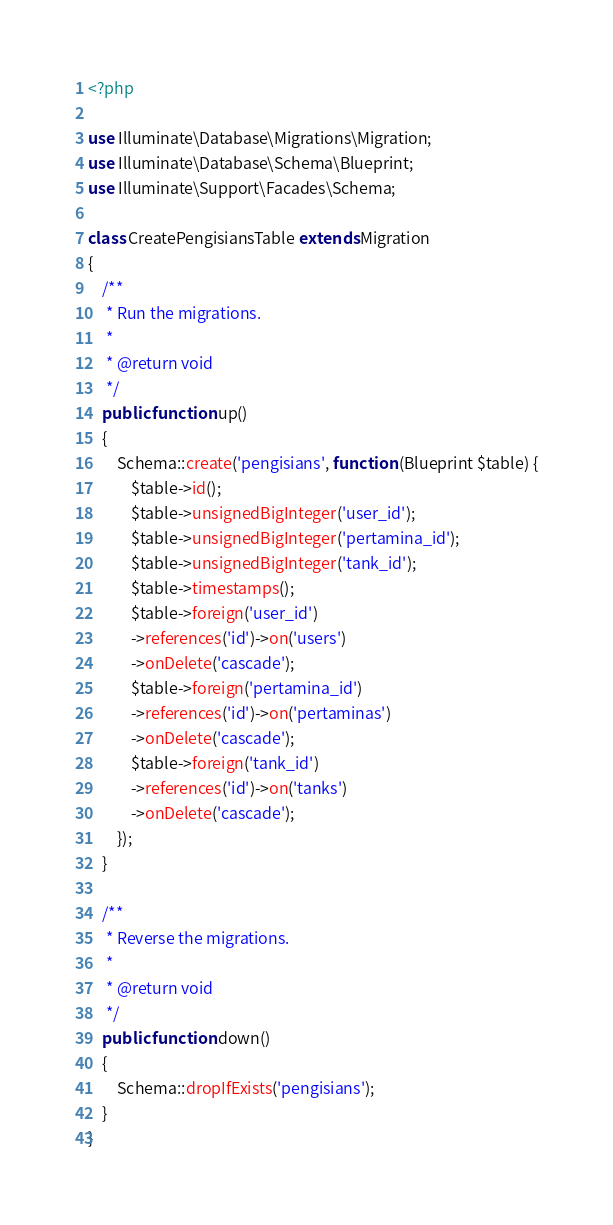Convert code to text. <code><loc_0><loc_0><loc_500><loc_500><_PHP_><?php

use Illuminate\Database\Migrations\Migration;
use Illuminate\Database\Schema\Blueprint;
use Illuminate\Support\Facades\Schema;

class CreatePengisiansTable extends Migration
{
    /**
     * Run the migrations.
     *
     * @return void
     */
    public function up()
    {
        Schema::create('pengisians', function (Blueprint $table) {
            $table->id();
            $table->unsignedBigInteger('user_id');
            $table->unsignedBigInteger('pertamina_id');
            $table->unsignedBigInteger('tank_id');
            $table->timestamps();
            $table->foreign('user_id')
            ->references('id')->on('users')
            ->onDelete('cascade');
            $table->foreign('pertamina_id')
            ->references('id')->on('pertaminas')
            ->onDelete('cascade');
            $table->foreign('tank_id')
            ->references('id')->on('tanks')
            ->onDelete('cascade');
        });
    }

    /**
     * Reverse the migrations.
     *
     * @return void
     */
    public function down()
    {
        Schema::dropIfExists('pengisians');
    }
}
</code> 